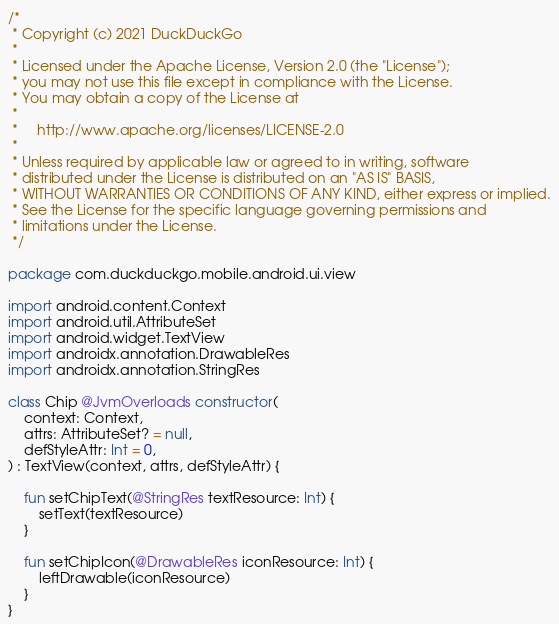Convert code to text. <code><loc_0><loc_0><loc_500><loc_500><_Kotlin_>/*
 * Copyright (c) 2021 DuckDuckGo
 *
 * Licensed under the Apache License, Version 2.0 (the "License");
 * you may not use this file except in compliance with the License.
 * You may obtain a copy of the License at
 *
 *     http://www.apache.org/licenses/LICENSE-2.0
 *
 * Unless required by applicable law or agreed to in writing, software
 * distributed under the License is distributed on an "AS IS" BASIS,
 * WITHOUT WARRANTIES OR CONDITIONS OF ANY KIND, either express or implied.
 * See the License for the specific language governing permissions and
 * limitations under the License.
 */

package com.duckduckgo.mobile.android.ui.view

import android.content.Context
import android.util.AttributeSet
import android.widget.TextView
import androidx.annotation.DrawableRes
import androidx.annotation.StringRes

class Chip @JvmOverloads constructor(
    context: Context,
    attrs: AttributeSet? = null,
    defStyleAttr: Int = 0,
) : TextView(context, attrs, defStyleAttr) {

    fun setChipText(@StringRes textResource: Int) {
        setText(textResource)
    }

    fun setChipIcon(@DrawableRes iconResource: Int) {
        leftDrawable(iconResource)
    }
}
</code> 